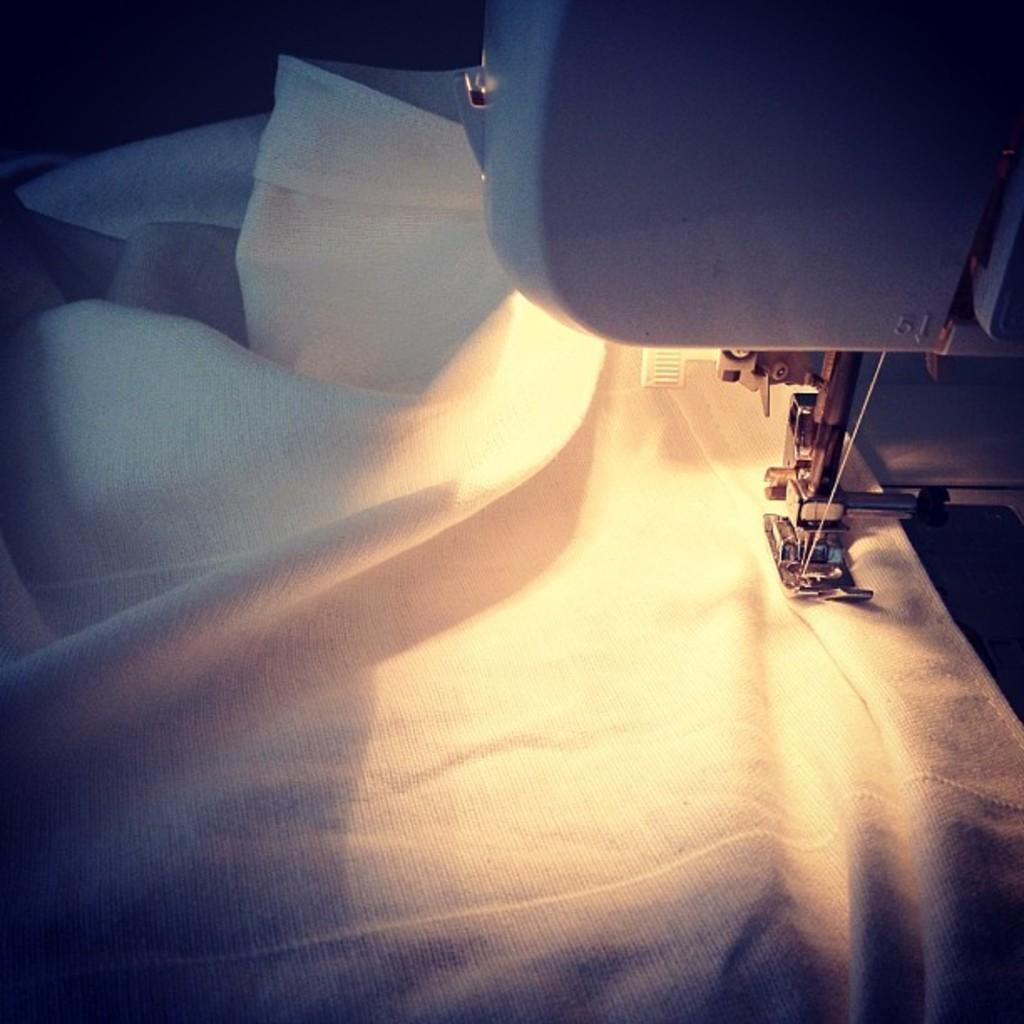What is the main object in the foreground of the image? There is a cloth on a sewing machine in the foreground of the image. What is the cloth being used for on the sewing machine? The specific use of the cloth on the sewing machine cannot be determined from the image alone. How many gold babies are playing with oil in the image? There are no gold babies or oil present in the image; it features a cloth on a sewing machine in the foreground. 